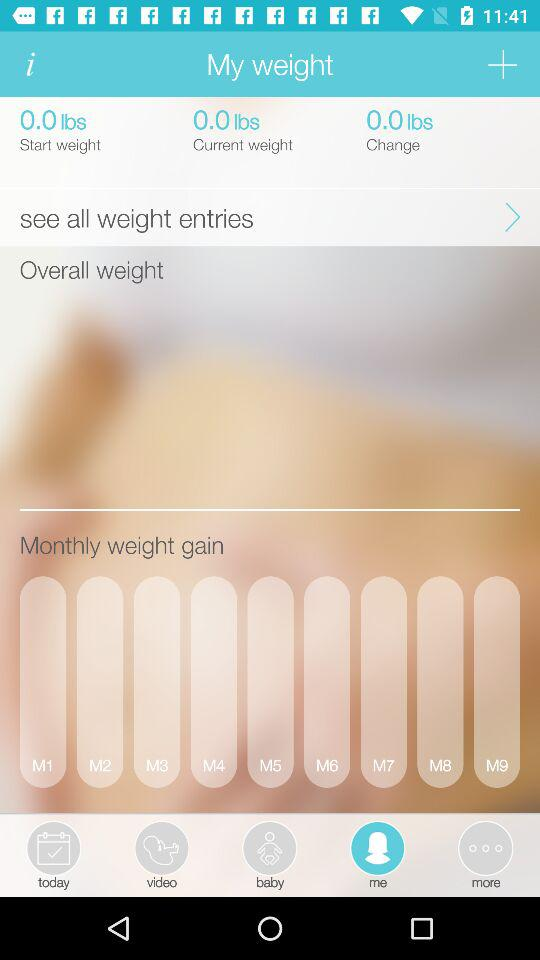How many items are available in "baby"?
When the provided information is insufficient, respond with <no answer>. <no answer> 